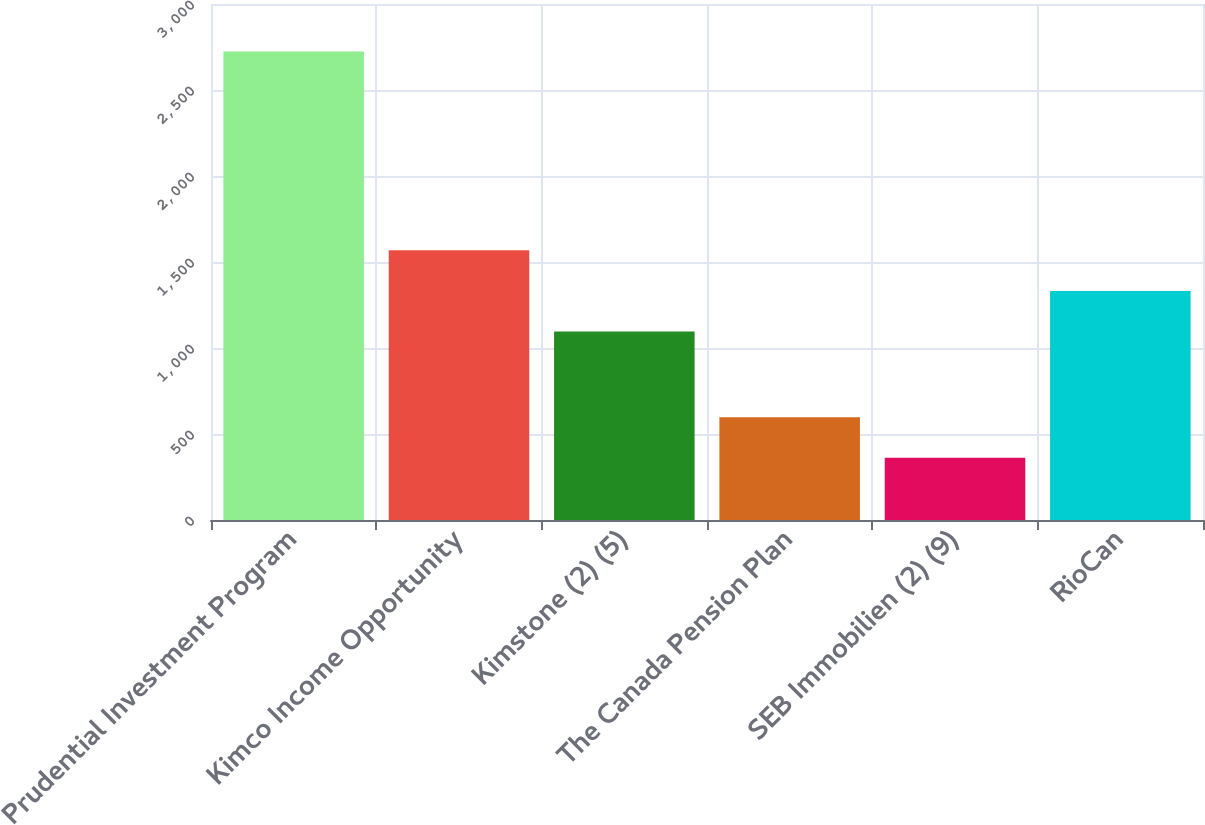Convert chart to OTSL. <chart><loc_0><loc_0><loc_500><loc_500><bar_chart><fcel>Prudential Investment Program<fcel>Kimco Income Opportunity<fcel>Kimstone (2) (5)<fcel>The Canada Pension Plan<fcel>SEB Immobilien (2) (9)<fcel>RioCan<nl><fcel>2724<fcel>1567.72<fcel>1095.3<fcel>598.11<fcel>361.9<fcel>1331.51<nl></chart> 